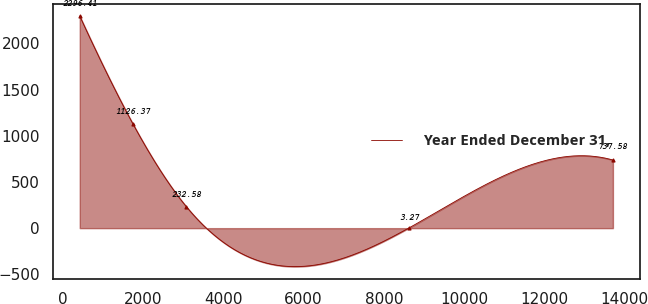Convert chart. <chart><loc_0><loc_0><loc_500><loc_500><line_chart><ecel><fcel>Year Ended December 31,<nl><fcel>421.87<fcel>2296.41<nl><fcel>1750.65<fcel>1126.37<nl><fcel>3079.43<fcel>232.58<nl><fcel>8629.59<fcel>3.27<nl><fcel>13709.7<fcel>737.58<nl></chart> 